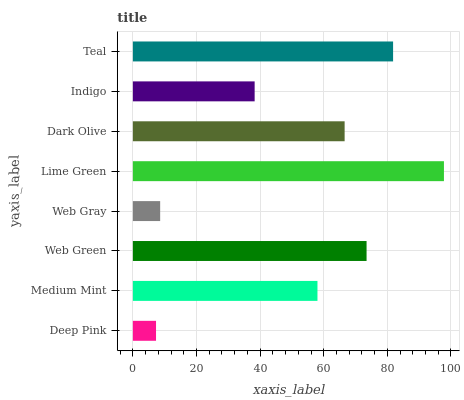Is Deep Pink the minimum?
Answer yes or no. Yes. Is Lime Green the maximum?
Answer yes or no. Yes. Is Medium Mint the minimum?
Answer yes or no. No. Is Medium Mint the maximum?
Answer yes or no. No. Is Medium Mint greater than Deep Pink?
Answer yes or no. Yes. Is Deep Pink less than Medium Mint?
Answer yes or no. Yes. Is Deep Pink greater than Medium Mint?
Answer yes or no. No. Is Medium Mint less than Deep Pink?
Answer yes or no. No. Is Dark Olive the high median?
Answer yes or no. Yes. Is Medium Mint the low median?
Answer yes or no. Yes. Is Medium Mint the high median?
Answer yes or no. No. Is Deep Pink the low median?
Answer yes or no. No. 